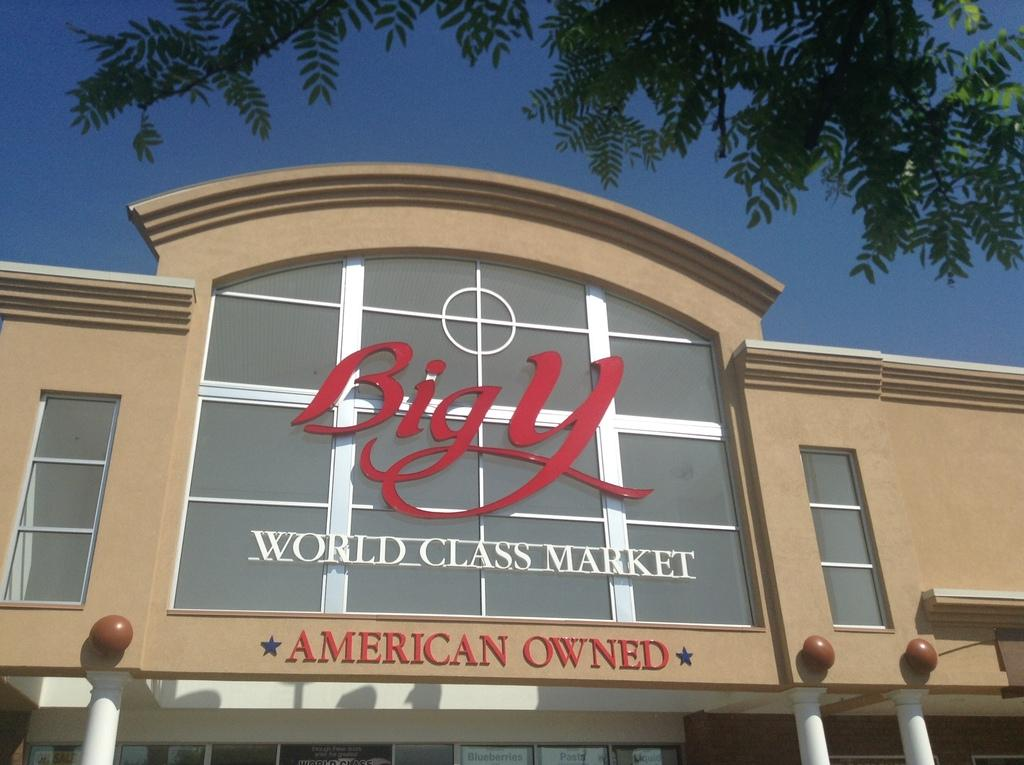What is the main subject in the foreground of the image? There is a building in the foreground of the image. What can be seen at the top of the image? There is a tree and the sky visible at the top of the image. What type of hair can be seen on the army soldiers in the image? There are no army soldiers or hair present in the image. What season is depicted in the image? The provided facts do not mention any seasonal details, so it cannot be determined from the image. 